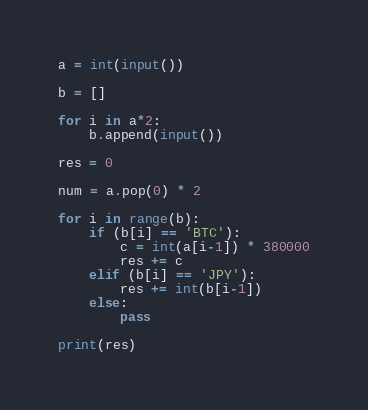<code> <loc_0><loc_0><loc_500><loc_500><_Python_>

a = int(input())

b = []

for i in a*2:
    b.append(input())

res = 0

num = a.pop(0) * 2

for i in range(b):
    if (b[i] == 'BTC'):
        c = int(a[i-1]) * 380000
        res += c
    elif (b[i] == 'JPY'):
        res += int(b[i-1])
    else:
        pass

print(res) </code> 